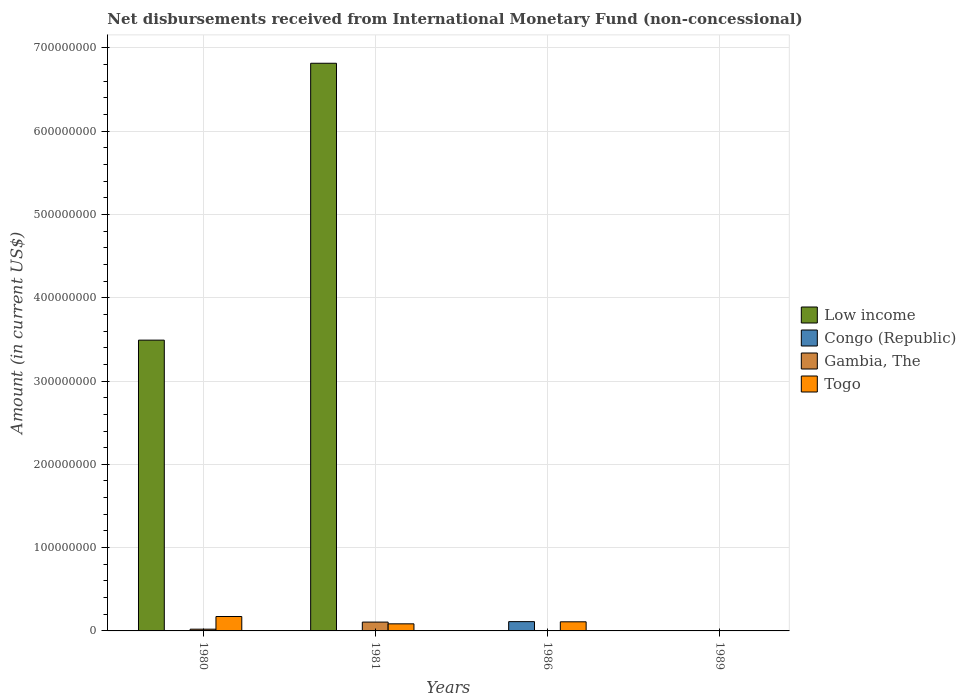How many different coloured bars are there?
Your answer should be compact. 4. Are the number of bars on each tick of the X-axis equal?
Offer a terse response. No. How many bars are there on the 2nd tick from the left?
Your answer should be compact. 3. How many bars are there on the 4th tick from the right?
Give a very brief answer. 3. What is the label of the 4th group of bars from the left?
Your answer should be compact. 1989. In how many cases, is the number of bars for a given year not equal to the number of legend labels?
Give a very brief answer. 4. Across all years, what is the maximum amount of disbursements received from International Monetary Fund in Low income?
Make the answer very short. 6.81e+08. In which year was the amount of disbursements received from International Monetary Fund in Togo maximum?
Your answer should be compact. 1980. What is the total amount of disbursements received from International Monetary Fund in Togo in the graph?
Your answer should be very brief. 3.67e+07. What is the difference between the amount of disbursements received from International Monetary Fund in Togo in 1981 and that in 1986?
Ensure brevity in your answer.  -2.44e+06. What is the difference between the amount of disbursements received from International Monetary Fund in Congo (Republic) in 1986 and the amount of disbursements received from International Monetary Fund in Low income in 1980?
Give a very brief answer. -3.38e+08. What is the average amount of disbursements received from International Monetary Fund in Low income per year?
Your answer should be very brief. 2.58e+08. In the year 1980, what is the difference between the amount of disbursements received from International Monetary Fund in Gambia, The and amount of disbursements received from International Monetary Fund in Togo?
Your answer should be very brief. -1.52e+07. In how many years, is the amount of disbursements received from International Monetary Fund in Low income greater than 260000000 US$?
Give a very brief answer. 2. What is the ratio of the amount of disbursements received from International Monetary Fund in Togo in 1980 to that in 1981?
Ensure brevity in your answer.  2.04. What is the difference between the highest and the second highest amount of disbursements received from International Monetary Fund in Togo?
Offer a very short reply. 6.36e+06. What is the difference between the highest and the lowest amount of disbursements received from International Monetary Fund in Low income?
Give a very brief answer. 6.81e+08. In how many years, is the amount of disbursements received from International Monetary Fund in Togo greater than the average amount of disbursements received from International Monetary Fund in Togo taken over all years?
Provide a short and direct response. 2. Is the sum of the amount of disbursements received from International Monetary Fund in Low income in 1980 and 1981 greater than the maximum amount of disbursements received from International Monetary Fund in Togo across all years?
Your answer should be very brief. Yes. Is it the case that in every year, the sum of the amount of disbursements received from International Monetary Fund in Low income and amount of disbursements received from International Monetary Fund in Gambia, The is greater than the amount of disbursements received from International Monetary Fund in Togo?
Provide a short and direct response. No. How many bars are there?
Make the answer very short. 8. How many legend labels are there?
Provide a short and direct response. 4. What is the title of the graph?
Provide a short and direct response. Net disbursements received from International Monetary Fund (non-concessional). What is the Amount (in current US$) of Low income in 1980?
Your answer should be very brief. 3.49e+08. What is the Amount (in current US$) in Gambia, The in 1980?
Ensure brevity in your answer.  2.10e+06. What is the Amount (in current US$) of Togo in 1980?
Keep it short and to the point. 1.73e+07. What is the Amount (in current US$) in Low income in 1981?
Offer a terse response. 6.81e+08. What is the Amount (in current US$) in Congo (Republic) in 1981?
Offer a terse response. 0. What is the Amount (in current US$) in Gambia, The in 1981?
Your response must be concise. 1.06e+07. What is the Amount (in current US$) in Togo in 1981?
Your response must be concise. 8.50e+06. What is the Amount (in current US$) of Congo (Republic) in 1986?
Keep it short and to the point. 1.12e+07. What is the Amount (in current US$) of Togo in 1986?
Offer a terse response. 1.09e+07. What is the Amount (in current US$) in Low income in 1989?
Keep it short and to the point. 0. Across all years, what is the maximum Amount (in current US$) of Low income?
Your answer should be compact. 6.81e+08. Across all years, what is the maximum Amount (in current US$) in Congo (Republic)?
Offer a terse response. 1.12e+07. Across all years, what is the maximum Amount (in current US$) of Gambia, The?
Your answer should be very brief. 1.06e+07. Across all years, what is the maximum Amount (in current US$) of Togo?
Provide a short and direct response. 1.73e+07. Across all years, what is the minimum Amount (in current US$) of Low income?
Keep it short and to the point. 0. Across all years, what is the minimum Amount (in current US$) in Togo?
Your answer should be compact. 0. What is the total Amount (in current US$) in Low income in the graph?
Give a very brief answer. 1.03e+09. What is the total Amount (in current US$) in Congo (Republic) in the graph?
Your response must be concise. 1.12e+07. What is the total Amount (in current US$) of Gambia, The in the graph?
Make the answer very short. 1.27e+07. What is the total Amount (in current US$) in Togo in the graph?
Offer a terse response. 3.67e+07. What is the difference between the Amount (in current US$) of Low income in 1980 and that in 1981?
Your answer should be very brief. -3.32e+08. What is the difference between the Amount (in current US$) of Gambia, The in 1980 and that in 1981?
Your answer should be compact. -8.50e+06. What is the difference between the Amount (in current US$) in Togo in 1980 and that in 1981?
Offer a terse response. 8.80e+06. What is the difference between the Amount (in current US$) in Togo in 1980 and that in 1986?
Provide a short and direct response. 6.36e+06. What is the difference between the Amount (in current US$) in Togo in 1981 and that in 1986?
Offer a very short reply. -2.44e+06. What is the difference between the Amount (in current US$) in Low income in 1980 and the Amount (in current US$) in Gambia, The in 1981?
Keep it short and to the point. 3.38e+08. What is the difference between the Amount (in current US$) of Low income in 1980 and the Amount (in current US$) of Togo in 1981?
Offer a terse response. 3.41e+08. What is the difference between the Amount (in current US$) of Gambia, The in 1980 and the Amount (in current US$) of Togo in 1981?
Provide a short and direct response. -6.40e+06. What is the difference between the Amount (in current US$) of Low income in 1980 and the Amount (in current US$) of Congo (Republic) in 1986?
Your answer should be compact. 3.38e+08. What is the difference between the Amount (in current US$) in Low income in 1980 and the Amount (in current US$) in Togo in 1986?
Provide a succinct answer. 3.38e+08. What is the difference between the Amount (in current US$) in Gambia, The in 1980 and the Amount (in current US$) in Togo in 1986?
Offer a terse response. -8.84e+06. What is the difference between the Amount (in current US$) of Low income in 1981 and the Amount (in current US$) of Congo (Republic) in 1986?
Your answer should be very brief. 6.70e+08. What is the difference between the Amount (in current US$) of Low income in 1981 and the Amount (in current US$) of Togo in 1986?
Provide a succinct answer. 6.71e+08. What is the average Amount (in current US$) of Low income per year?
Your answer should be compact. 2.58e+08. What is the average Amount (in current US$) in Congo (Republic) per year?
Provide a succinct answer. 2.79e+06. What is the average Amount (in current US$) of Gambia, The per year?
Your answer should be compact. 3.18e+06. What is the average Amount (in current US$) of Togo per year?
Your answer should be very brief. 9.18e+06. In the year 1980, what is the difference between the Amount (in current US$) of Low income and Amount (in current US$) of Gambia, The?
Your response must be concise. 3.47e+08. In the year 1980, what is the difference between the Amount (in current US$) in Low income and Amount (in current US$) in Togo?
Ensure brevity in your answer.  3.32e+08. In the year 1980, what is the difference between the Amount (in current US$) in Gambia, The and Amount (in current US$) in Togo?
Your response must be concise. -1.52e+07. In the year 1981, what is the difference between the Amount (in current US$) in Low income and Amount (in current US$) in Gambia, The?
Provide a short and direct response. 6.71e+08. In the year 1981, what is the difference between the Amount (in current US$) of Low income and Amount (in current US$) of Togo?
Offer a very short reply. 6.73e+08. In the year 1981, what is the difference between the Amount (in current US$) of Gambia, The and Amount (in current US$) of Togo?
Make the answer very short. 2.10e+06. What is the ratio of the Amount (in current US$) of Low income in 1980 to that in 1981?
Offer a terse response. 0.51. What is the ratio of the Amount (in current US$) of Gambia, The in 1980 to that in 1981?
Your answer should be compact. 0.2. What is the ratio of the Amount (in current US$) of Togo in 1980 to that in 1981?
Make the answer very short. 2.04. What is the ratio of the Amount (in current US$) in Togo in 1980 to that in 1986?
Keep it short and to the point. 1.58. What is the ratio of the Amount (in current US$) in Togo in 1981 to that in 1986?
Give a very brief answer. 0.78. What is the difference between the highest and the second highest Amount (in current US$) of Togo?
Your answer should be very brief. 6.36e+06. What is the difference between the highest and the lowest Amount (in current US$) in Low income?
Provide a succinct answer. 6.81e+08. What is the difference between the highest and the lowest Amount (in current US$) of Congo (Republic)?
Offer a very short reply. 1.12e+07. What is the difference between the highest and the lowest Amount (in current US$) of Gambia, The?
Give a very brief answer. 1.06e+07. What is the difference between the highest and the lowest Amount (in current US$) of Togo?
Your answer should be very brief. 1.73e+07. 